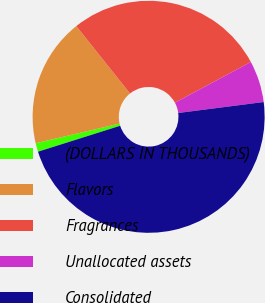Convert chart. <chart><loc_0><loc_0><loc_500><loc_500><pie_chart><fcel>(DOLLARS IN THOUSANDS)<fcel>Flavors<fcel>Fragrances<fcel>Unallocated assets<fcel>Consolidated<nl><fcel>1.21%<fcel>17.94%<fcel>27.88%<fcel>5.8%<fcel>47.17%<nl></chart> 